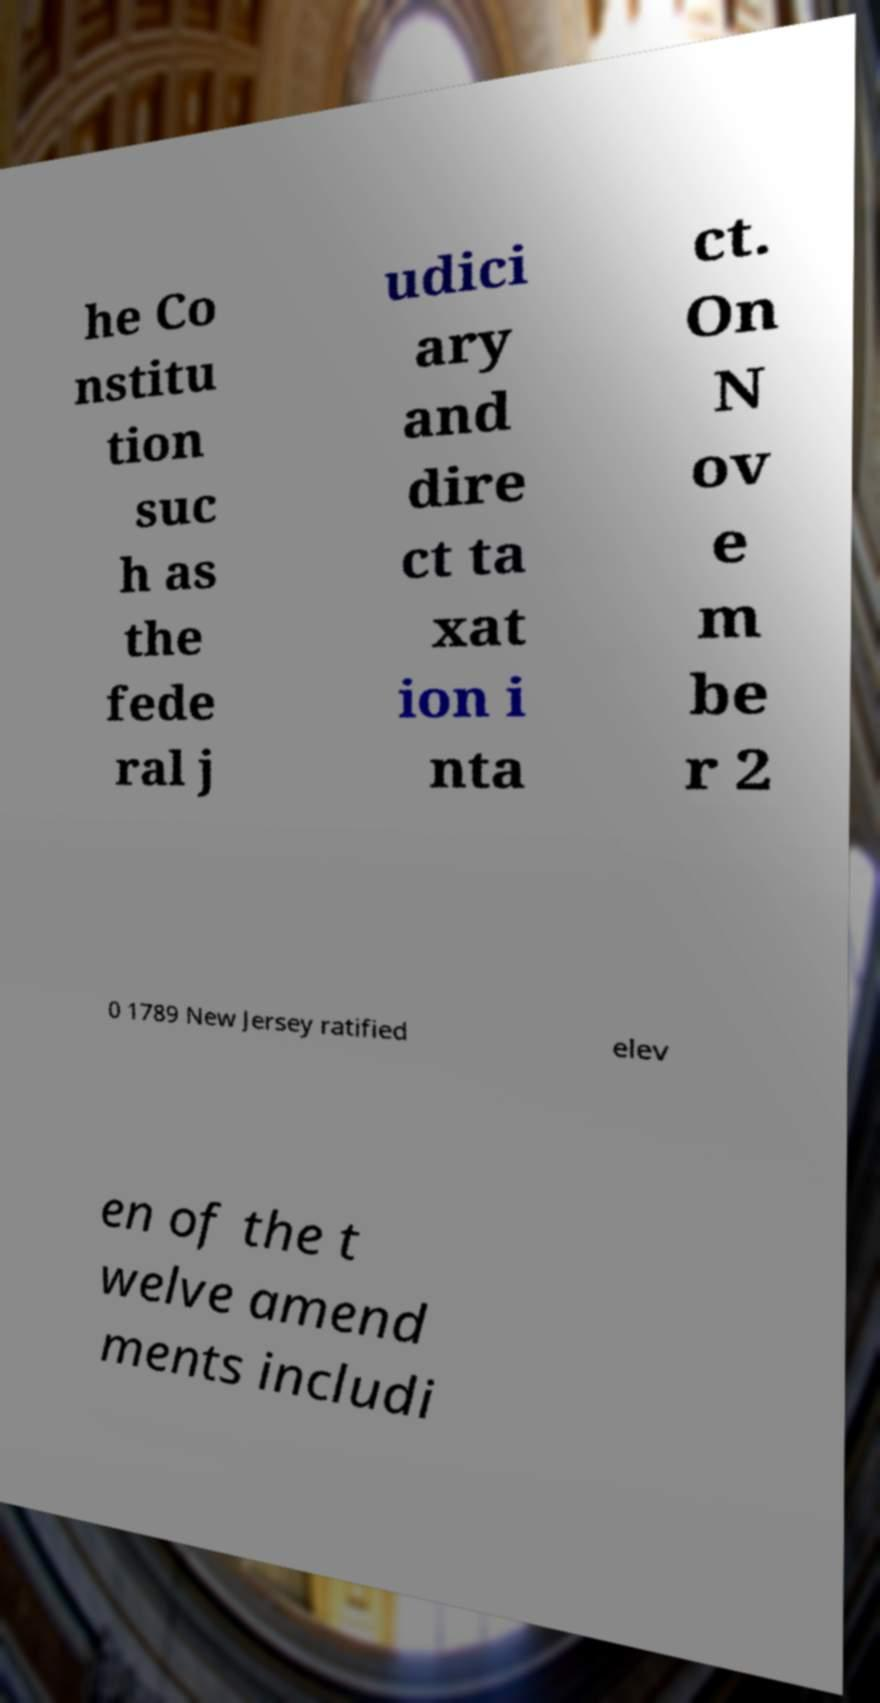I need the written content from this picture converted into text. Can you do that? he Co nstitu tion suc h as the fede ral j udici ary and dire ct ta xat ion i nta ct. On N ov e m be r 2 0 1789 New Jersey ratified elev en of the t welve amend ments includi 